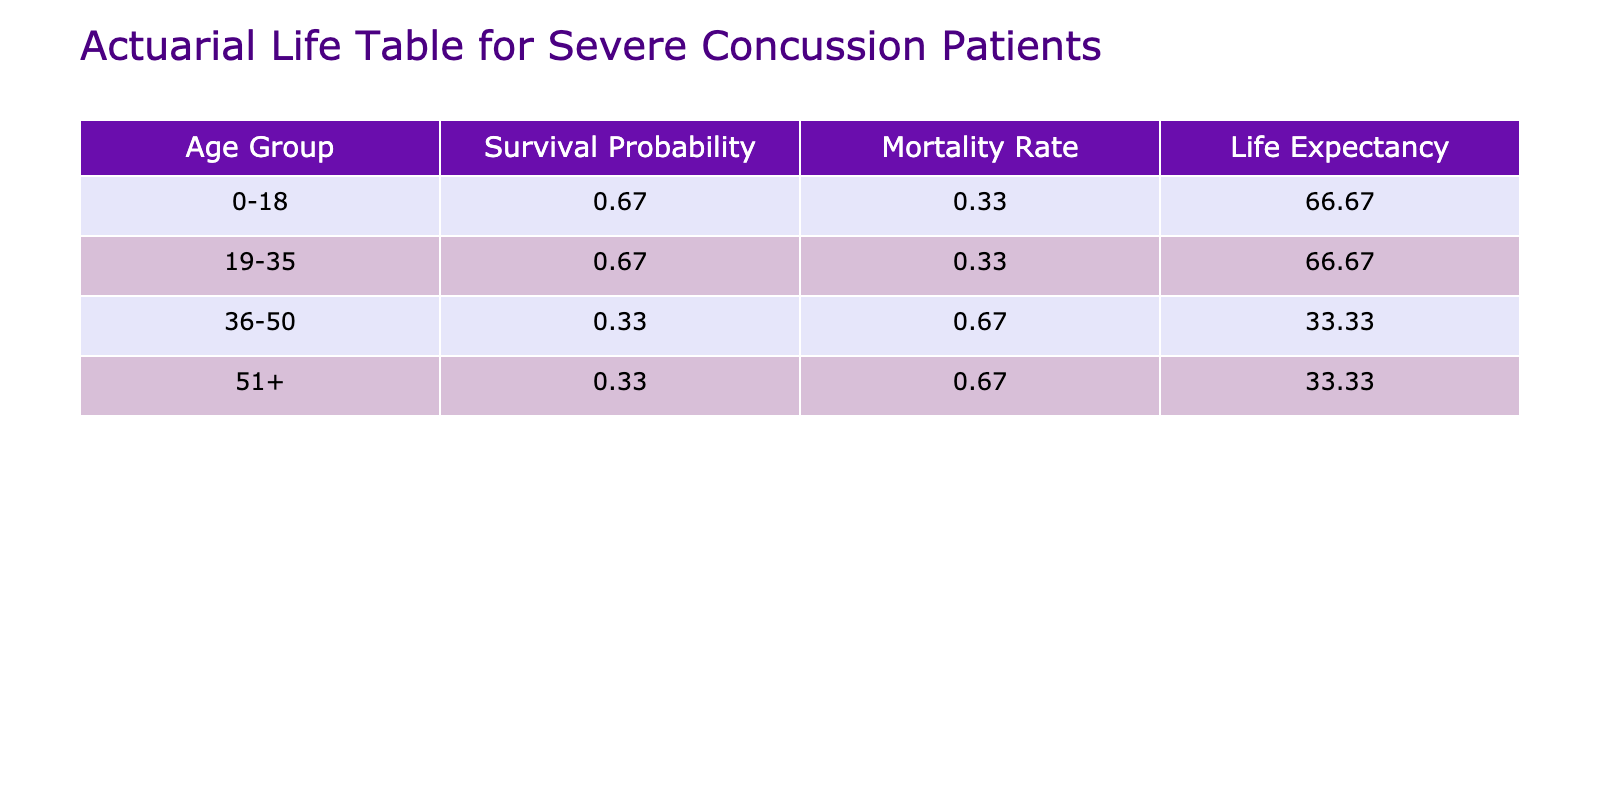What is the survival probability for the 51+ age group? In the table, we look at the 'Survival Probability' column for the 51+ age group. There are three patients in this group, but only one survived, leading to a survival probability of 1/3 = 0.33.
Answer: 0.33 What is the mortality rate for females aged 19-35? For the females in the 19-35 age group, we find two patients. One of them died, while the other survived. Thus, the mortality rate is 1 - (1/2) = 0.50.
Answer: 0.50 Which age group has the highest survival probability? By comparing the survival probabilities for each age group, we see 0.33 for 51+, 0.50 for 36-50, and 0.67 for 19-35, while 0.67 applies to 0-18. The highest is for the 0-18 age group at 0.67.
Answer: 0-18 What percentage of the patients in the 36-50 age group died? There are three patients in this age group, two of whom died. Therefore, the percentage who died is (2/3) * 100 = 66.67%.
Answer: 66.67% Is it true that all patients with an initial GCS score of 15 survived? In the table, we check every entry with an initial GCS score of 15. There are three patients. All survived, therefore, the statement is true.
Answer: Yes What is the average life expectancy among males and females aged 0-18? The survival probabilities are 0.67 for males and 0.50 for females aged 0-18. The average life expectancy is (0.67 + 0.50)/2 * 100 = 58.5.
Answer: 58.5 What is the difference in mortality rates between the 51+ age group and the 0-18 age group? The mortality rate for the 51+ age group is 0.67, while for the 0-18 age group it is 0.33. Therefore, the difference is 0.67 - 0.33 = 0.34.
Answer: 0.34 What is the total number of patients who survived across all age groups? To find the total number of survivors, we count the instances of 'No' in the Mortality column. There are 5 survivors in total across the age groups.
Answer: 5 What is the probability of survival for patients over 50 compared to those under 50? For patients over 50 (0.33) versus those under 50 (0.6 average of 0-18(0.67), 19-35(0.67), and 36-50(0.50)). Therefore, the comparison shows a significant difference in survival probability.
Answer: 0.6 (under 50), 0.33 (over 50) 